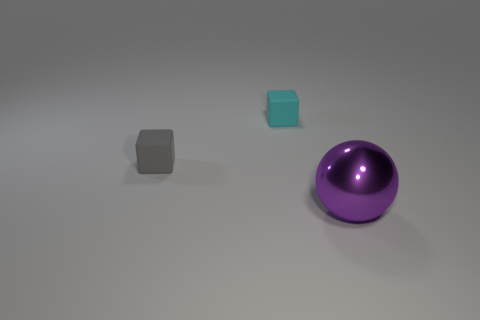What is the shape of the rubber object that is to the right of the small gray rubber thing?
Provide a short and direct response. Cube. There is a rubber thing that is in front of the small cyan block; is there a big purple metallic thing on the left side of it?
Ensure brevity in your answer.  No. What color is the object that is in front of the tiny cyan rubber object and to the left of the purple shiny object?
Provide a short and direct response. Gray. Is there a tiny cube that is left of the tiny rubber cube that is right of the rubber thing in front of the cyan block?
Your answer should be compact. Yes. What is the size of the cyan matte thing that is the same shape as the small gray object?
Keep it short and to the point. Small. Is there any other thing that has the same material as the big purple sphere?
Your answer should be very brief. No. Are any big gray matte cylinders visible?
Provide a succinct answer. No. There is a ball; is it the same color as the tiny cube that is on the left side of the tiny cyan matte cube?
Make the answer very short. No. There is a matte object that is on the left side of the small cube that is behind the small matte thing in front of the small cyan rubber object; what size is it?
Offer a terse response. Small. What number of large shiny balls are the same color as the shiny object?
Ensure brevity in your answer.  0. 